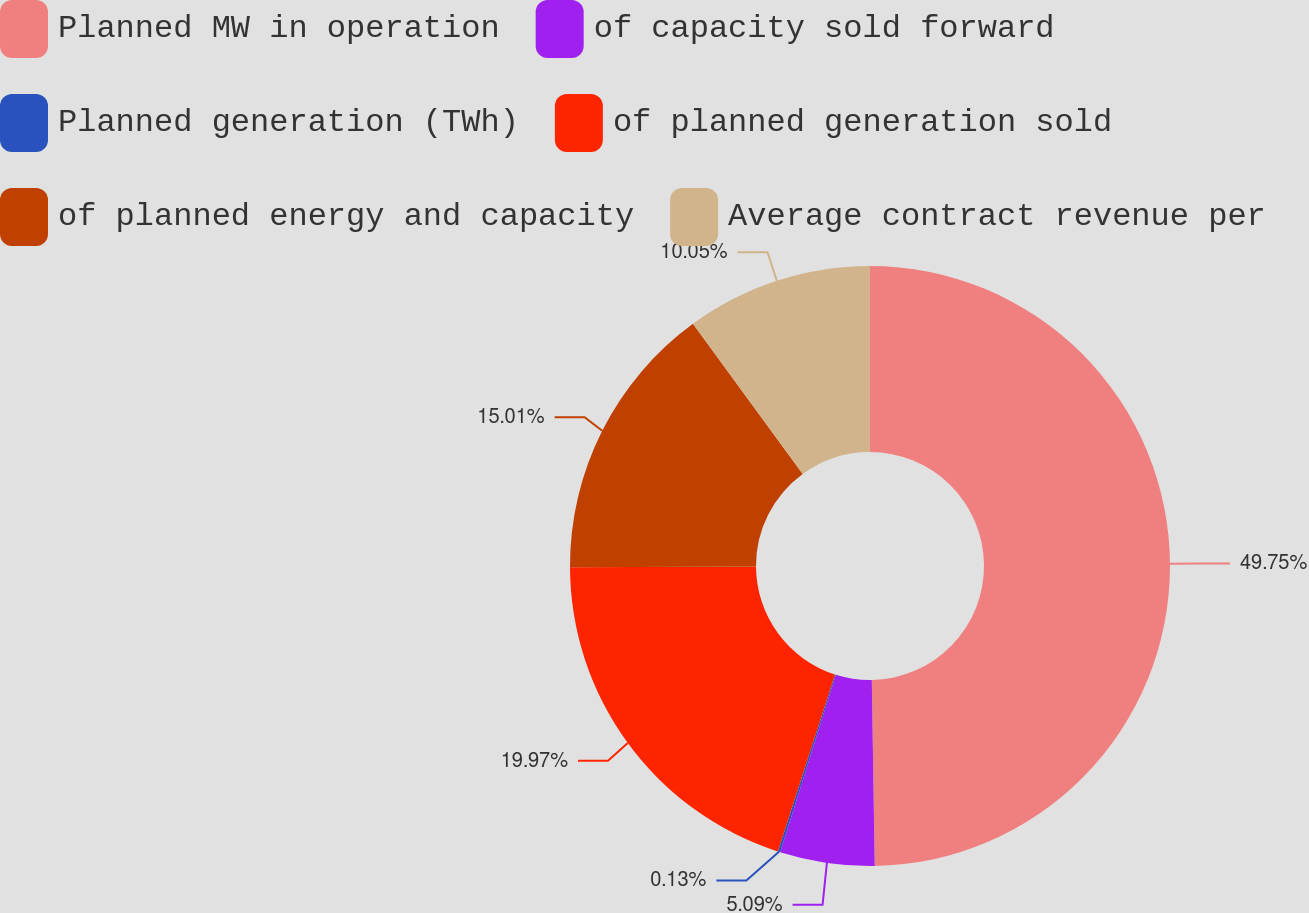Convert chart to OTSL. <chart><loc_0><loc_0><loc_500><loc_500><pie_chart><fcel>Planned MW in operation<fcel>of capacity sold forward<fcel>Planned generation (TWh)<fcel>of planned generation sold<fcel>of planned energy and capacity<fcel>Average contract revenue per<nl><fcel>49.75%<fcel>5.09%<fcel>0.13%<fcel>19.97%<fcel>15.01%<fcel>10.05%<nl></chart> 